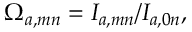<formula> <loc_0><loc_0><loc_500><loc_500>\Omega _ { a , m n } = I _ { a , m n } / I _ { a , 0 n } ,</formula> 